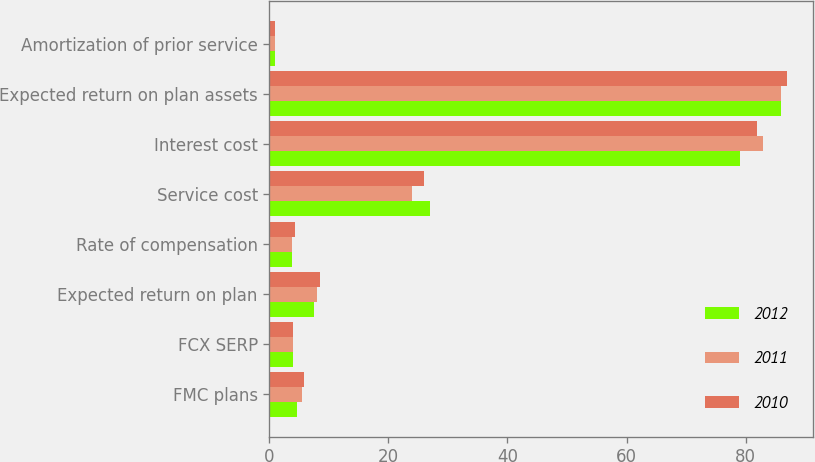Convert chart to OTSL. <chart><loc_0><loc_0><loc_500><loc_500><stacked_bar_chart><ecel><fcel>FMC plans<fcel>FCX SERP<fcel>Expected return on plan<fcel>Rate of compensation<fcel>Service cost<fcel>Interest cost<fcel>Expected return on plan assets<fcel>Amortization of prior service<nl><fcel>2012<fcel>4.6<fcel>4<fcel>7.5<fcel>3.75<fcel>27<fcel>79<fcel>86<fcel>1<nl><fcel>2011<fcel>5.4<fcel>4<fcel>8<fcel>3.75<fcel>24<fcel>83<fcel>86<fcel>1<nl><fcel>2010<fcel>5.8<fcel>4<fcel>8.5<fcel>4.25<fcel>26<fcel>82<fcel>87<fcel>1<nl></chart> 